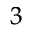<formula> <loc_0><loc_0><loc_500><loc_500>_ { 3 }</formula> 